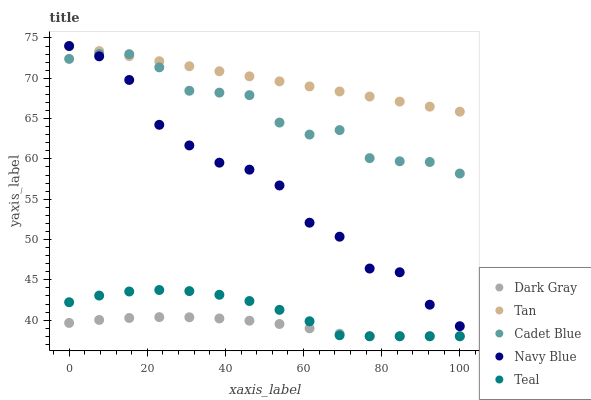Does Dark Gray have the minimum area under the curve?
Answer yes or no. Yes. Does Tan have the maximum area under the curve?
Answer yes or no. Yes. Does Navy Blue have the minimum area under the curve?
Answer yes or no. No. Does Navy Blue have the maximum area under the curve?
Answer yes or no. No. Is Tan the smoothest?
Answer yes or no. Yes. Is Navy Blue the roughest?
Answer yes or no. Yes. Is Navy Blue the smoothest?
Answer yes or no. No. Is Tan the roughest?
Answer yes or no. No. Does Dark Gray have the lowest value?
Answer yes or no. Yes. Does Navy Blue have the lowest value?
Answer yes or no. No. Does Tan have the highest value?
Answer yes or no. Yes. Does Cadet Blue have the highest value?
Answer yes or no. No. Is Teal less than Tan?
Answer yes or no. Yes. Is Tan greater than Teal?
Answer yes or no. Yes. Does Dark Gray intersect Teal?
Answer yes or no. Yes. Is Dark Gray less than Teal?
Answer yes or no. No. Is Dark Gray greater than Teal?
Answer yes or no. No. Does Teal intersect Tan?
Answer yes or no. No. 